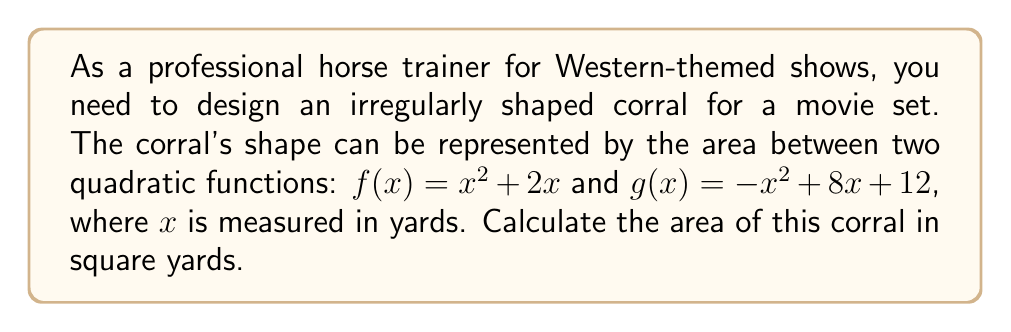Can you answer this question? To find the area of the irregularly shaped corral, we need to:

1. Find the points of intersection of the two functions.
2. Calculate the area between the curves.

Step 1: Find the points of intersection
Set the functions equal to each other:
$$x^2+2x = -x^2+8x+12$$
$$2x^2-6x-12 = 0$$

Use the quadratic formula: $x = \frac{-b \pm \sqrt{b^2-4ac}}{2a}$
Where $a=2$, $b=-6$, and $c=-12$

$$x = \frac{6 \pm \sqrt{36+96}}{4} = \frac{6 \pm \sqrt{132}}{4} = \frac{6 \pm 2\sqrt{33}}{4}$$

$x_1 = \frac{6 + 2\sqrt{33}}{4} \approx 4.37$ yards
$x_2 = \frac{6 - 2\sqrt{33}}{4} \approx 1.63$ yards

Step 2: Calculate the area between the curves
The area is given by the integral of the difference between the upper and lower functions:

$$A = \int_{x_2}^{x_1} [g(x) - f(x)] dx$$
$$A = \int_{1.63}^{4.37} [(-x^2+8x+12) - (x^2+2x)] dx$$
$$A = \int_{1.63}^{4.37} [-2x^2+6x+12] dx$$

Antiderivative:
$$A = [-\frac{2}{3}x^3+3x^2+12x]_{1.63}^{4.37}$$

Evaluate:
$$A = [-\frac{2}{3}(4.37)^3+3(4.37)^2+12(4.37)] - [-\frac{2}{3}(1.63)^3+3(1.63)^2+12(1.63)]$$
$$A \approx 44.44 - 8.44 = 36$$

Therefore, the area of the corral is approximately 36 square yards.
Answer: 36 square yards 